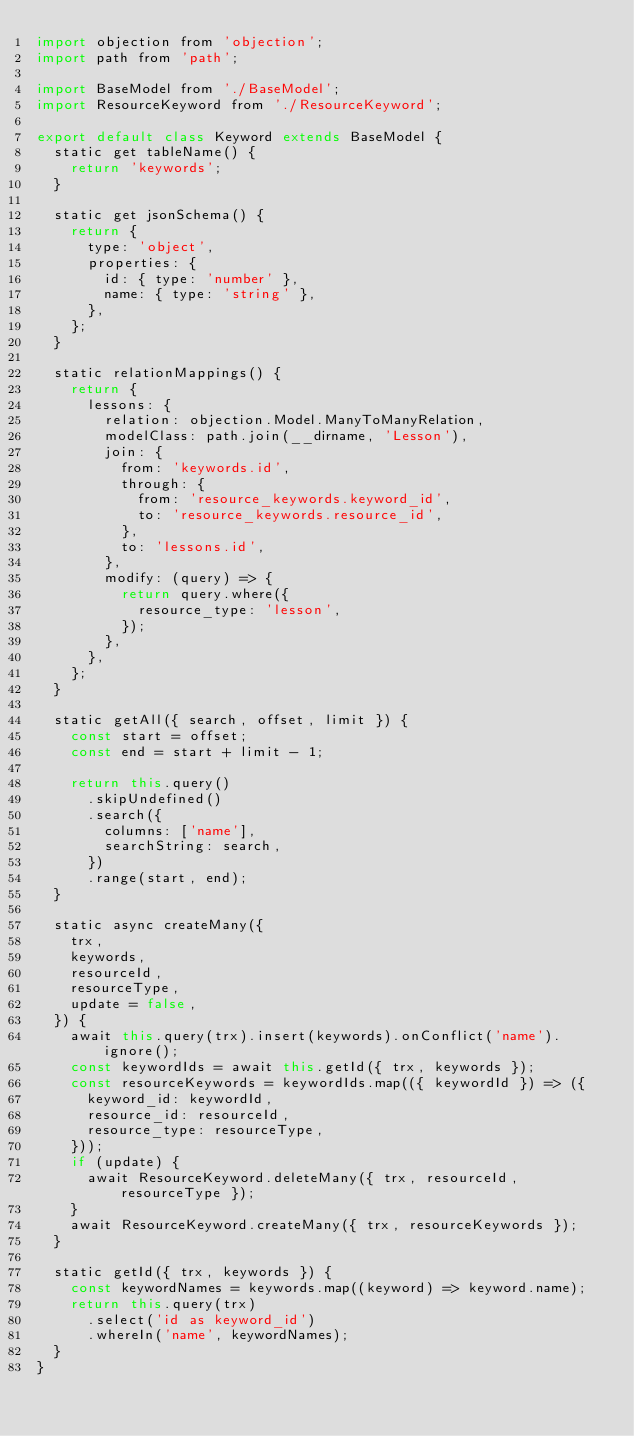Convert code to text. <code><loc_0><loc_0><loc_500><loc_500><_JavaScript_>import objection from 'objection';
import path from 'path';

import BaseModel from './BaseModel';
import ResourceKeyword from './ResourceKeyword';

export default class Keyword extends BaseModel {
  static get tableName() {
    return 'keywords';
  }

  static get jsonSchema() {
    return {
      type: 'object',
      properties: {
        id: { type: 'number' },
        name: { type: 'string' },
      },
    };
  }

  static relationMappings() {
    return {
      lessons: {
        relation: objection.Model.ManyToManyRelation,
        modelClass: path.join(__dirname, 'Lesson'),
        join: {
          from: 'keywords.id',
          through: {
            from: 'resource_keywords.keyword_id',
            to: 'resource_keywords.resource_id',
          },
          to: 'lessons.id',
        },
        modify: (query) => {
          return query.where({
            resource_type: 'lesson',
          });
        },
      },
    };
  }

  static getAll({ search, offset, limit }) {
    const start = offset;
    const end = start + limit - 1;

    return this.query()
      .skipUndefined()
      .search({
        columns: ['name'],
        searchString: search,
      })
      .range(start, end);
  }

  static async createMany({
    trx,
    keywords,
    resourceId,
    resourceType,
    update = false,
  }) {
    await this.query(trx).insert(keywords).onConflict('name').ignore();
    const keywordIds = await this.getId({ trx, keywords });
    const resourceKeywords = keywordIds.map(({ keywordId }) => ({
      keyword_id: keywordId,
      resource_id: resourceId,
      resource_type: resourceType,
    }));
    if (update) {
      await ResourceKeyword.deleteMany({ trx, resourceId, resourceType });
    }
    await ResourceKeyword.createMany({ trx, resourceKeywords });
  }

  static getId({ trx, keywords }) {
    const keywordNames = keywords.map((keyword) => keyword.name);
    return this.query(trx)
      .select('id as keyword_id')
      .whereIn('name', keywordNames);
  }
}
</code> 